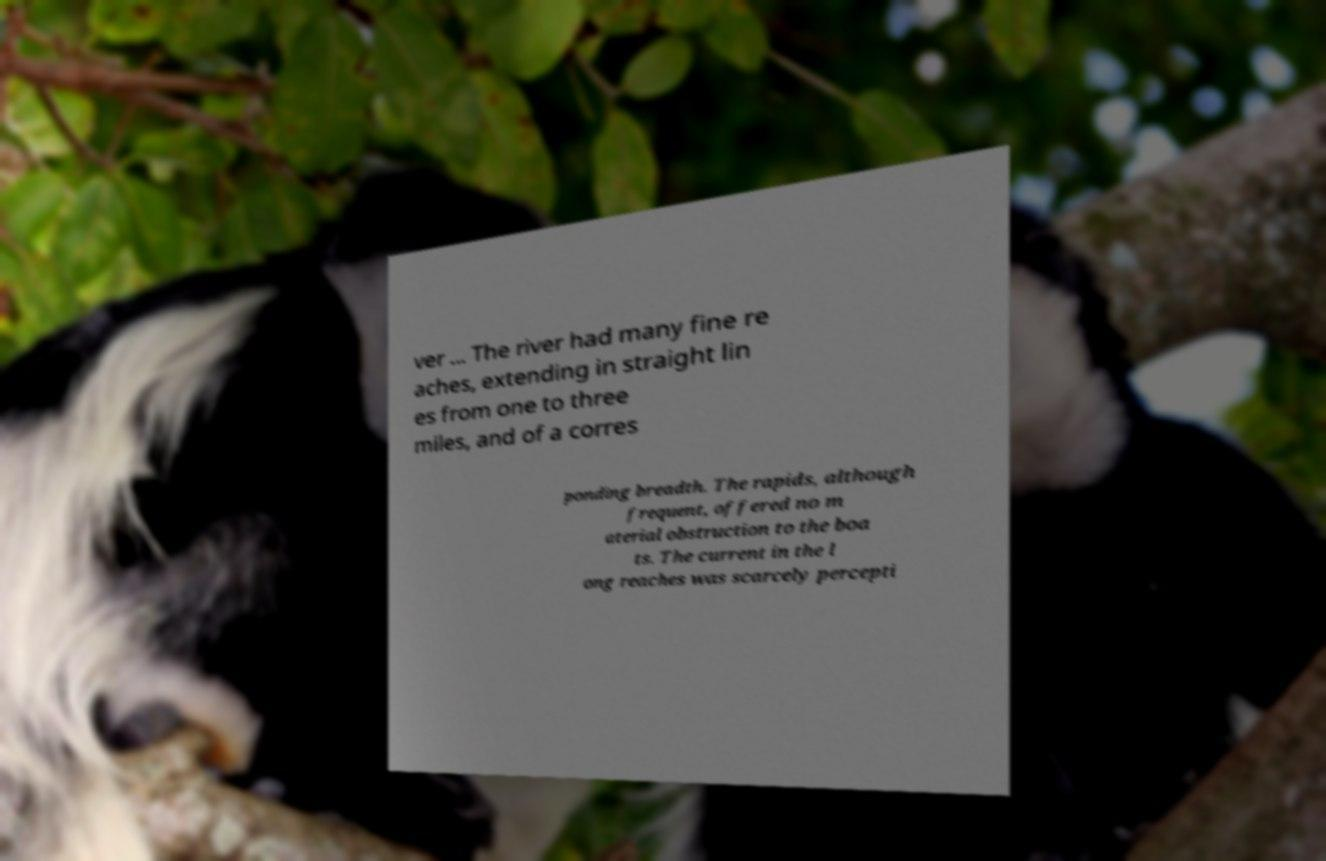There's text embedded in this image that I need extracted. Can you transcribe it verbatim? ver ... The river had many fine re aches, extending in straight lin es from one to three miles, and of a corres ponding breadth. The rapids, although frequent, offered no m aterial obstruction to the boa ts. The current in the l ong reaches was scarcely percepti 